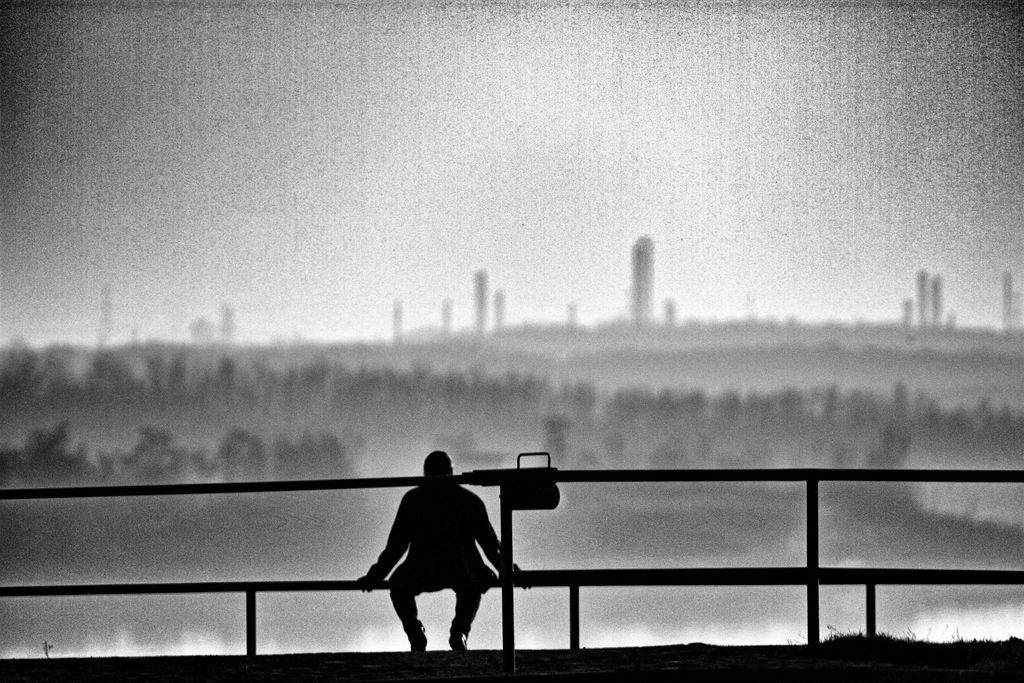What is the person in the image doing? There is a person sitting in the image. What type of natural environment is visible in the image? There is grass in the image. What architectural feature can be seen in the image? There is a fence in the image. What type of bait is the person using to catch fish in the image? There is no indication of fishing or bait in the image; the person is simply sitting. 